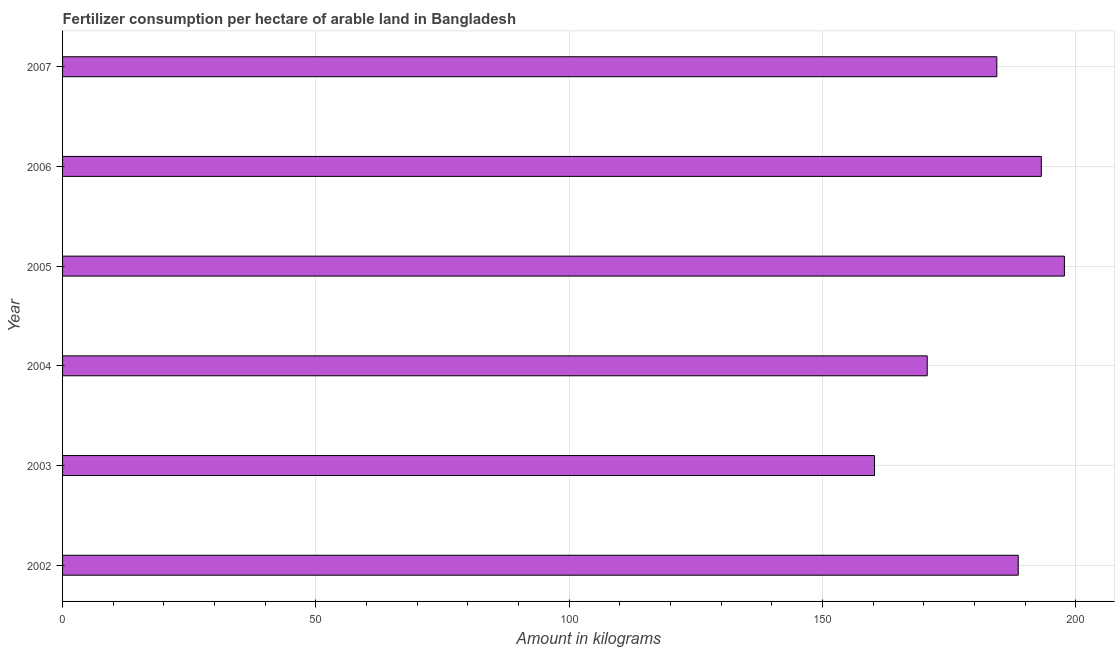Does the graph contain any zero values?
Make the answer very short. No. Does the graph contain grids?
Provide a short and direct response. Yes. What is the title of the graph?
Your answer should be very brief. Fertilizer consumption per hectare of arable land in Bangladesh . What is the label or title of the X-axis?
Give a very brief answer. Amount in kilograms. What is the amount of fertilizer consumption in 2007?
Offer a terse response. 184.41. Across all years, what is the maximum amount of fertilizer consumption?
Keep it short and to the point. 197.75. Across all years, what is the minimum amount of fertilizer consumption?
Ensure brevity in your answer.  160.27. In which year was the amount of fertilizer consumption minimum?
Your response must be concise. 2003. What is the sum of the amount of fertilizer consumption?
Make the answer very short. 1094.93. What is the difference between the amount of fertilizer consumption in 2003 and 2005?
Your answer should be very brief. -37.48. What is the average amount of fertilizer consumption per year?
Ensure brevity in your answer.  182.49. What is the median amount of fertilizer consumption?
Provide a short and direct response. 186.53. Do a majority of the years between 2002 and 2006 (inclusive) have amount of fertilizer consumption greater than 180 kg?
Ensure brevity in your answer.  Yes. What is the ratio of the amount of fertilizer consumption in 2006 to that in 2007?
Provide a short and direct response. 1.05. Is the difference between the amount of fertilizer consumption in 2003 and 2006 greater than the difference between any two years?
Your answer should be very brief. No. What is the difference between the highest and the second highest amount of fertilizer consumption?
Make the answer very short. 4.56. Is the sum of the amount of fertilizer consumption in 2003 and 2006 greater than the maximum amount of fertilizer consumption across all years?
Offer a terse response. Yes. What is the difference between the highest and the lowest amount of fertilizer consumption?
Offer a terse response. 37.48. Are all the bars in the graph horizontal?
Ensure brevity in your answer.  Yes. How many years are there in the graph?
Ensure brevity in your answer.  6. What is the Amount in kilograms of 2002?
Provide a short and direct response. 188.64. What is the Amount in kilograms of 2003?
Your answer should be compact. 160.27. What is the Amount in kilograms of 2004?
Give a very brief answer. 170.67. What is the Amount in kilograms of 2005?
Make the answer very short. 197.75. What is the Amount in kilograms of 2006?
Your answer should be very brief. 193.19. What is the Amount in kilograms of 2007?
Provide a succinct answer. 184.41. What is the difference between the Amount in kilograms in 2002 and 2003?
Provide a short and direct response. 28.37. What is the difference between the Amount in kilograms in 2002 and 2004?
Provide a succinct answer. 17.97. What is the difference between the Amount in kilograms in 2002 and 2005?
Your answer should be very brief. -9.11. What is the difference between the Amount in kilograms in 2002 and 2006?
Give a very brief answer. -4.55. What is the difference between the Amount in kilograms in 2002 and 2007?
Keep it short and to the point. 4.23. What is the difference between the Amount in kilograms in 2003 and 2004?
Make the answer very short. -10.4. What is the difference between the Amount in kilograms in 2003 and 2005?
Keep it short and to the point. -37.48. What is the difference between the Amount in kilograms in 2003 and 2006?
Ensure brevity in your answer.  -32.92. What is the difference between the Amount in kilograms in 2003 and 2007?
Your response must be concise. -24.14. What is the difference between the Amount in kilograms in 2004 and 2005?
Your answer should be compact. -27.08. What is the difference between the Amount in kilograms in 2004 and 2006?
Keep it short and to the point. -22.52. What is the difference between the Amount in kilograms in 2004 and 2007?
Your response must be concise. -13.74. What is the difference between the Amount in kilograms in 2005 and 2006?
Ensure brevity in your answer.  4.56. What is the difference between the Amount in kilograms in 2005 and 2007?
Provide a short and direct response. 13.34. What is the difference between the Amount in kilograms in 2006 and 2007?
Ensure brevity in your answer.  8.78. What is the ratio of the Amount in kilograms in 2002 to that in 2003?
Give a very brief answer. 1.18. What is the ratio of the Amount in kilograms in 2002 to that in 2004?
Make the answer very short. 1.1. What is the ratio of the Amount in kilograms in 2002 to that in 2005?
Your answer should be very brief. 0.95. What is the ratio of the Amount in kilograms in 2003 to that in 2004?
Make the answer very short. 0.94. What is the ratio of the Amount in kilograms in 2003 to that in 2005?
Give a very brief answer. 0.81. What is the ratio of the Amount in kilograms in 2003 to that in 2006?
Offer a terse response. 0.83. What is the ratio of the Amount in kilograms in 2003 to that in 2007?
Offer a terse response. 0.87. What is the ratio of the Amount in kilograms in 2004 to that in 2005?
Give a very brief answer. 0.86. What is the ratio of the Amount in kilograms in 2004 to that in 2006?
Provide a succinct answer. 0.88. What is the ratio of the Amount in kilograms in 2004 to that in 2007?
Provide a short and direct response. 0.93. What is the ratio of the Amount in kilograms in 2005 to that in 2007?
Ensure brevity in your answer.  1.07. What is the ratio of the Amount in kilograms in 2006 to that in 2007?
Offer a terse response. 1.05. 